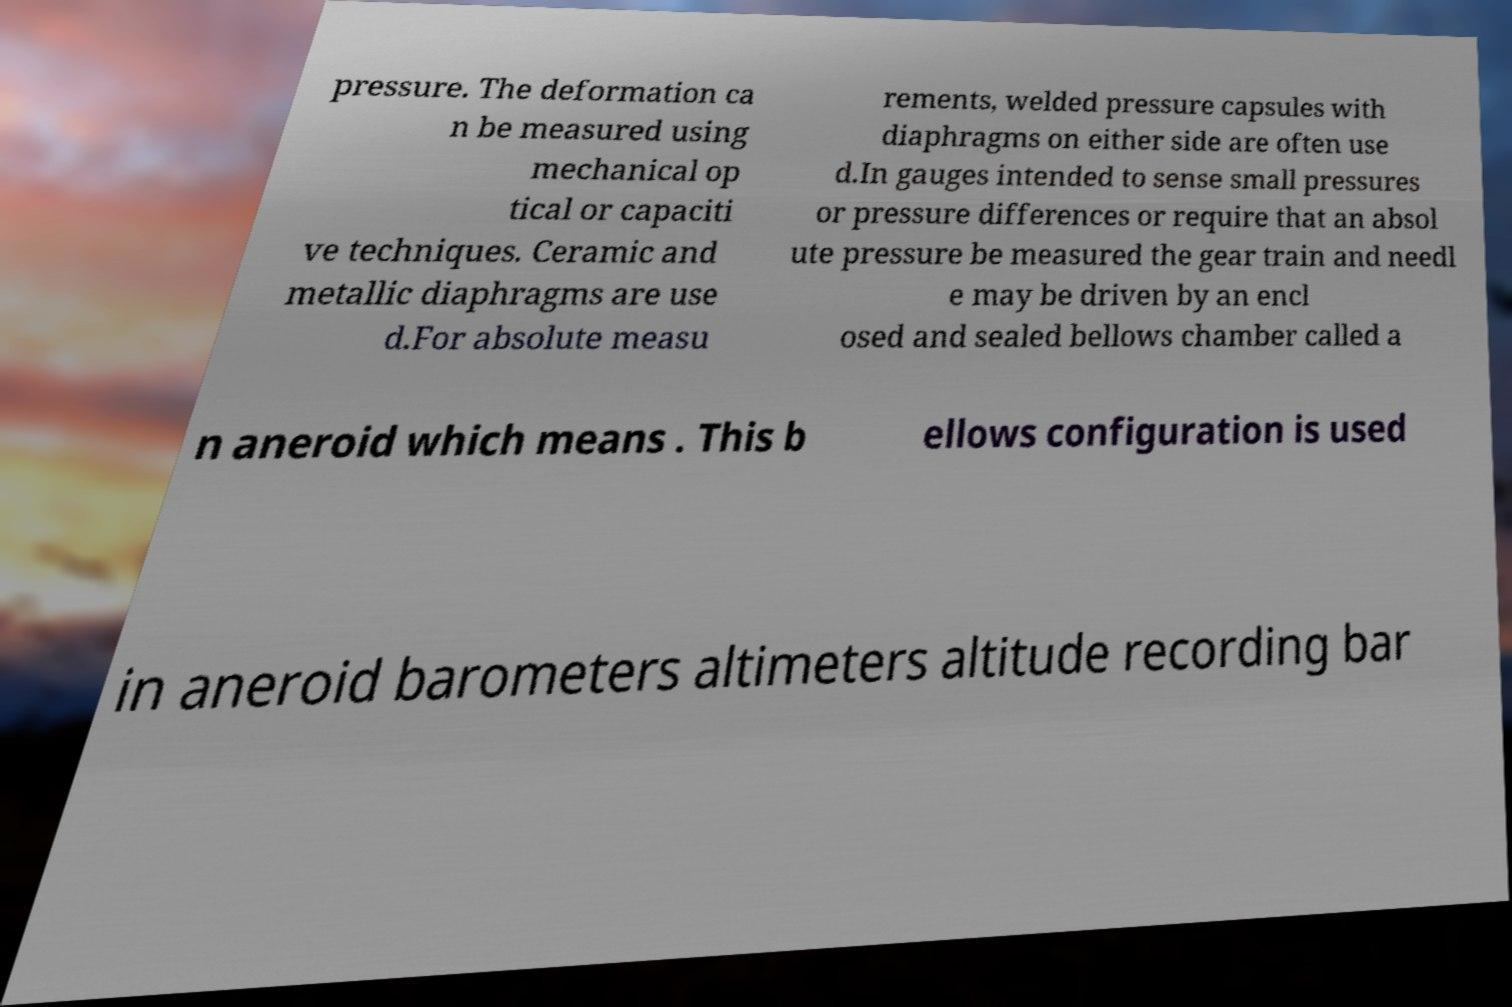Please read and relay the text visible in this image. What does it say? pressure. The deformation ca n be measured using mechanical op tical or capaciti ve techniques. Ceramic and metallic diaphragms are use d.For absolute measu rements, welded pressure capsules with diaphragms on either side are often use d.In gauges intended to sense small pressures or pressure differences or require that an absol ute pressure be measured the gear train and needl e may be driven by an encl osed and sealed bellows chamber called a n aneroid which means . This b ellows configuration is used in aneroid barometers altimeters altitude recording bar 